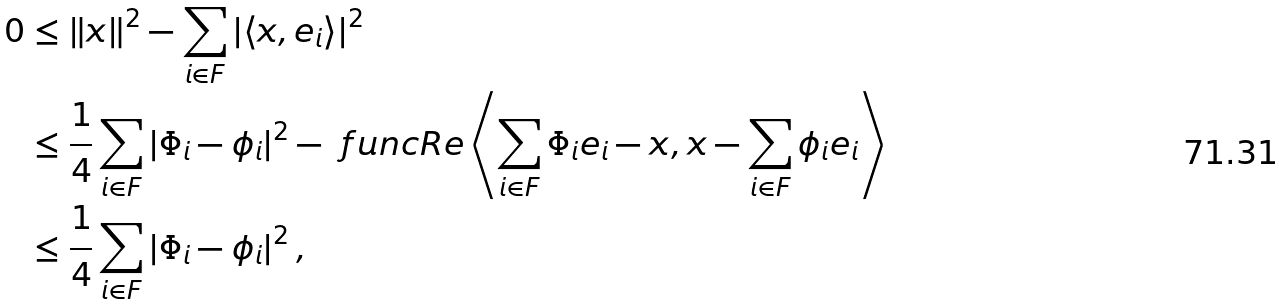<formula> <loc_0><loc_0><loc_500><loc_500>0 & \leq \left \| x \right \| ^ { 2 } - \sum _ { i \in F } \left | \left \langle x , e _ { i } \right \rangle \right | ^ { 2 } \\ & \leq \frac { 1 } { 4 } \sum _ { i \in F } \left | \Phi _ { i } - \phi _ { i } \right | ^ { 2 } - \ f u n c { R e } \left \langle \sum _ { i \in F } \Phi _ { i } e _ { i } - x , x - \sum _ { i \in F } \phi _ { i } e _ { i } \right \rangle \\ & \leq \frac { 1 } { 4 } \sum _ { i \in F } \left | \Phi _ { i } - \phi _ { i } \right | ^ { 2 } ,</formula> 